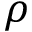Convert formula to latex. <formula><loc_0><loc_0><loc_500><loc_500>\rho</formula> 